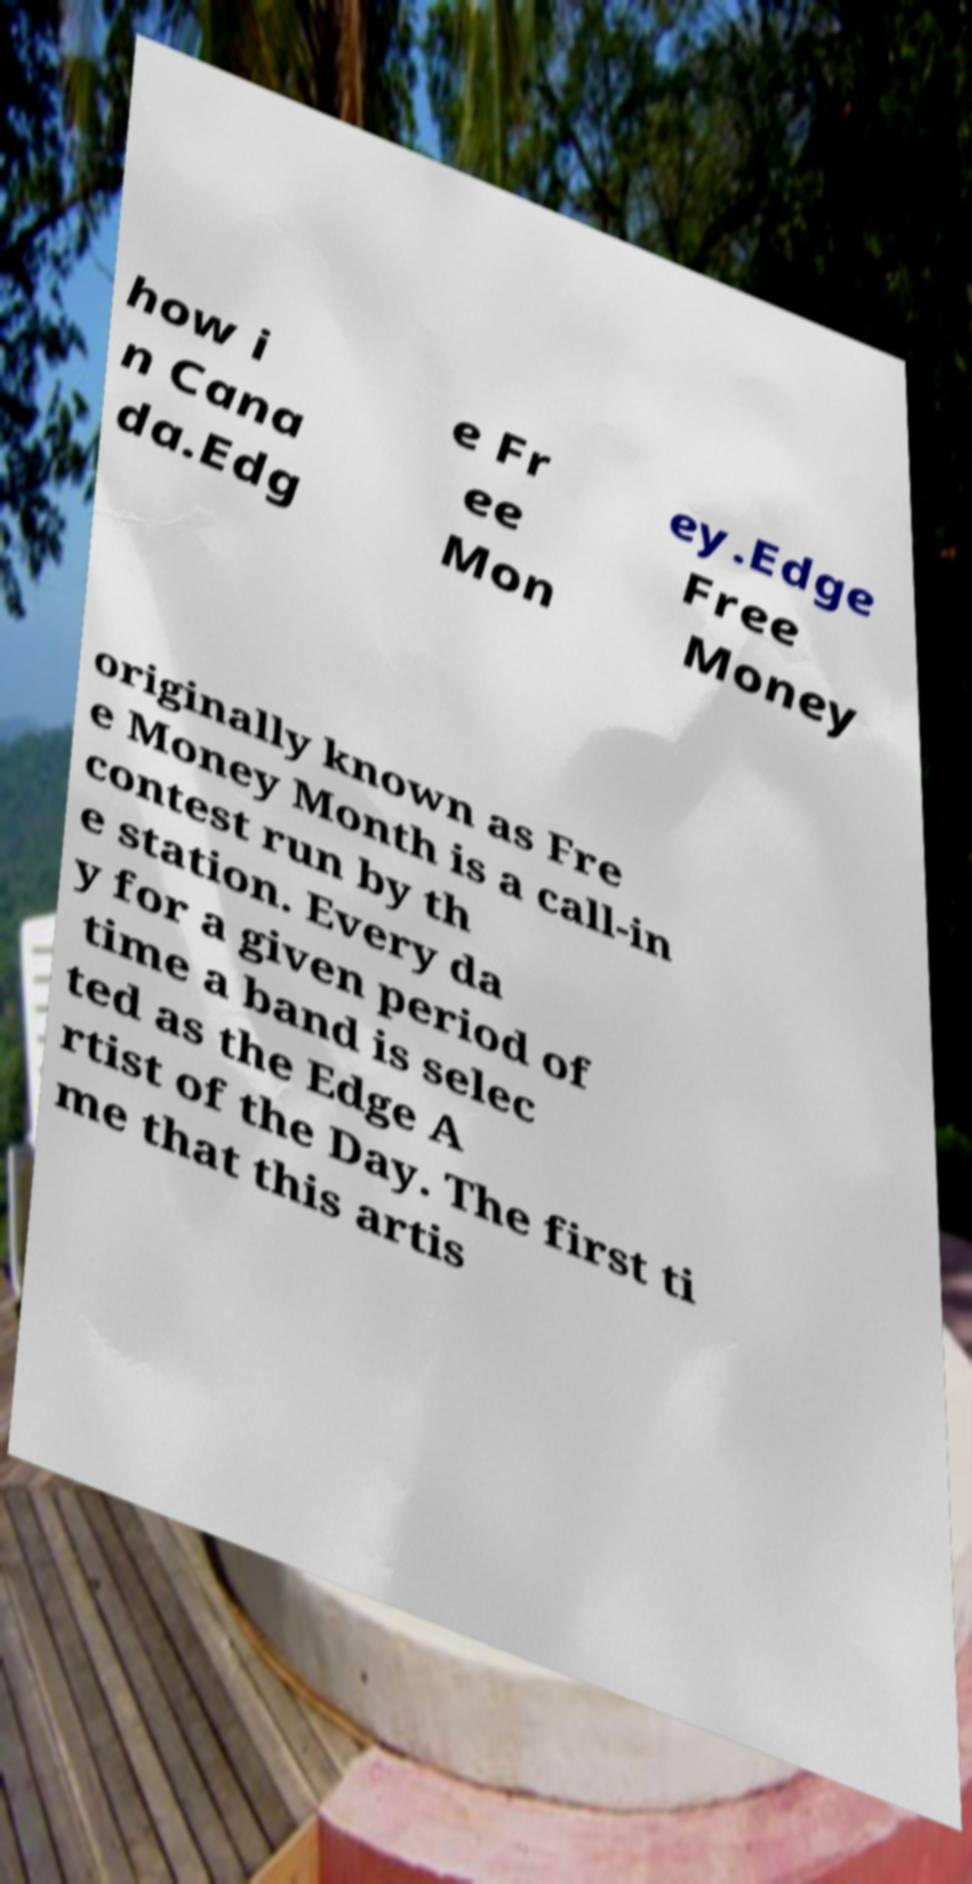Please read and relay the text visible in this image. What does it say? how i n Cana da.Edg e Fr ee Mon ey.Edge Free Money originally known as Fre e Money Month is a call-in contest run by th e station. Every da y for a given period of time a band is selec ted as the Edge A rtist of the Day. The first ti me that this artis 